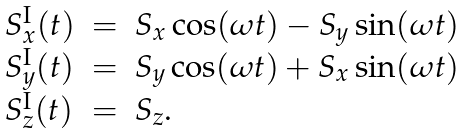Convert formula to latex. <formula><loc_0><loc_0><loc_500><loc_500>\begin{array} { l l l } S _ { x } ^ { \text {I} } ( t ) & = & S _ { x } \cos ( \omega t ) - S _ { y } \sin ( \omega t ) \\ S _ { y } ^ { \text {I} } ( t ) & = & S _ { y } \cos ( \omega t ) + S _ { x } \sin ( \omega t ) \\ S _ { z } ^ { \text {I} } ( t ) & = & S _ { z } . \end{array}</formula> 